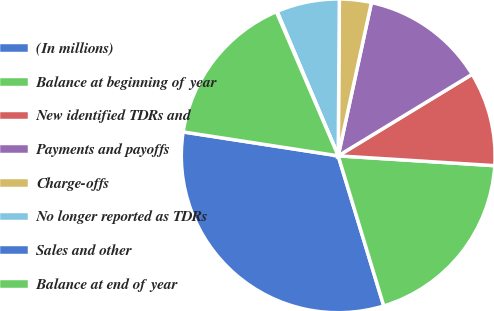Convert chart to OTSL. <chart><loc_0><loc_0><loc_500><loc_500><pie_chart><fcel>(In millions)<fcel>Balance at beginning of year<fcel>New identified TDRs and<fcel>Payments and payoffs<fcel>Charge-offs<fcel>No longer reported as TDRs<fcel>Sales and other<fcel>Balance at end of year<nl><fcel>32.13%<fcel>19.31%<fcel>9.7%<fcel>12.9%<fcel>3.28%<fcel>6.49%<fcel>0.08%<fcel>16.11%<nl></chart> 